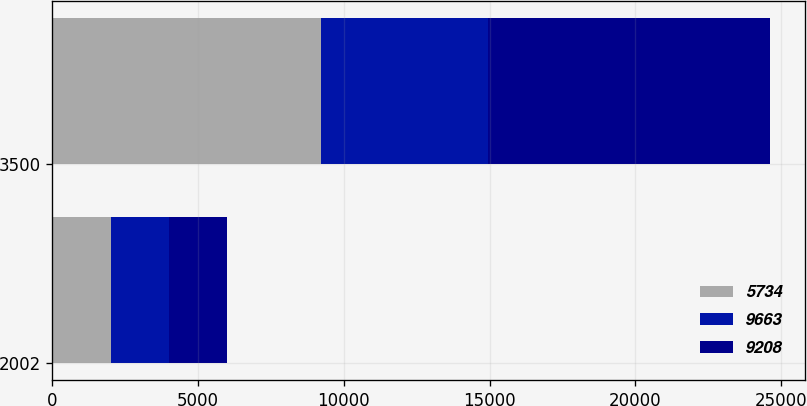<chart> <loc_0><loc_0><loc_500><loc_500><stacked_bar_chart><ecel><fcel>2002<fcel>3500<nl><fcel>5734<fcel>2001<fcel>9208<nl><fcel>9663<fcel>2000<fcel>5734<nl><fcel>9208<fcel>1999<fcel>9663<nl></chart> 